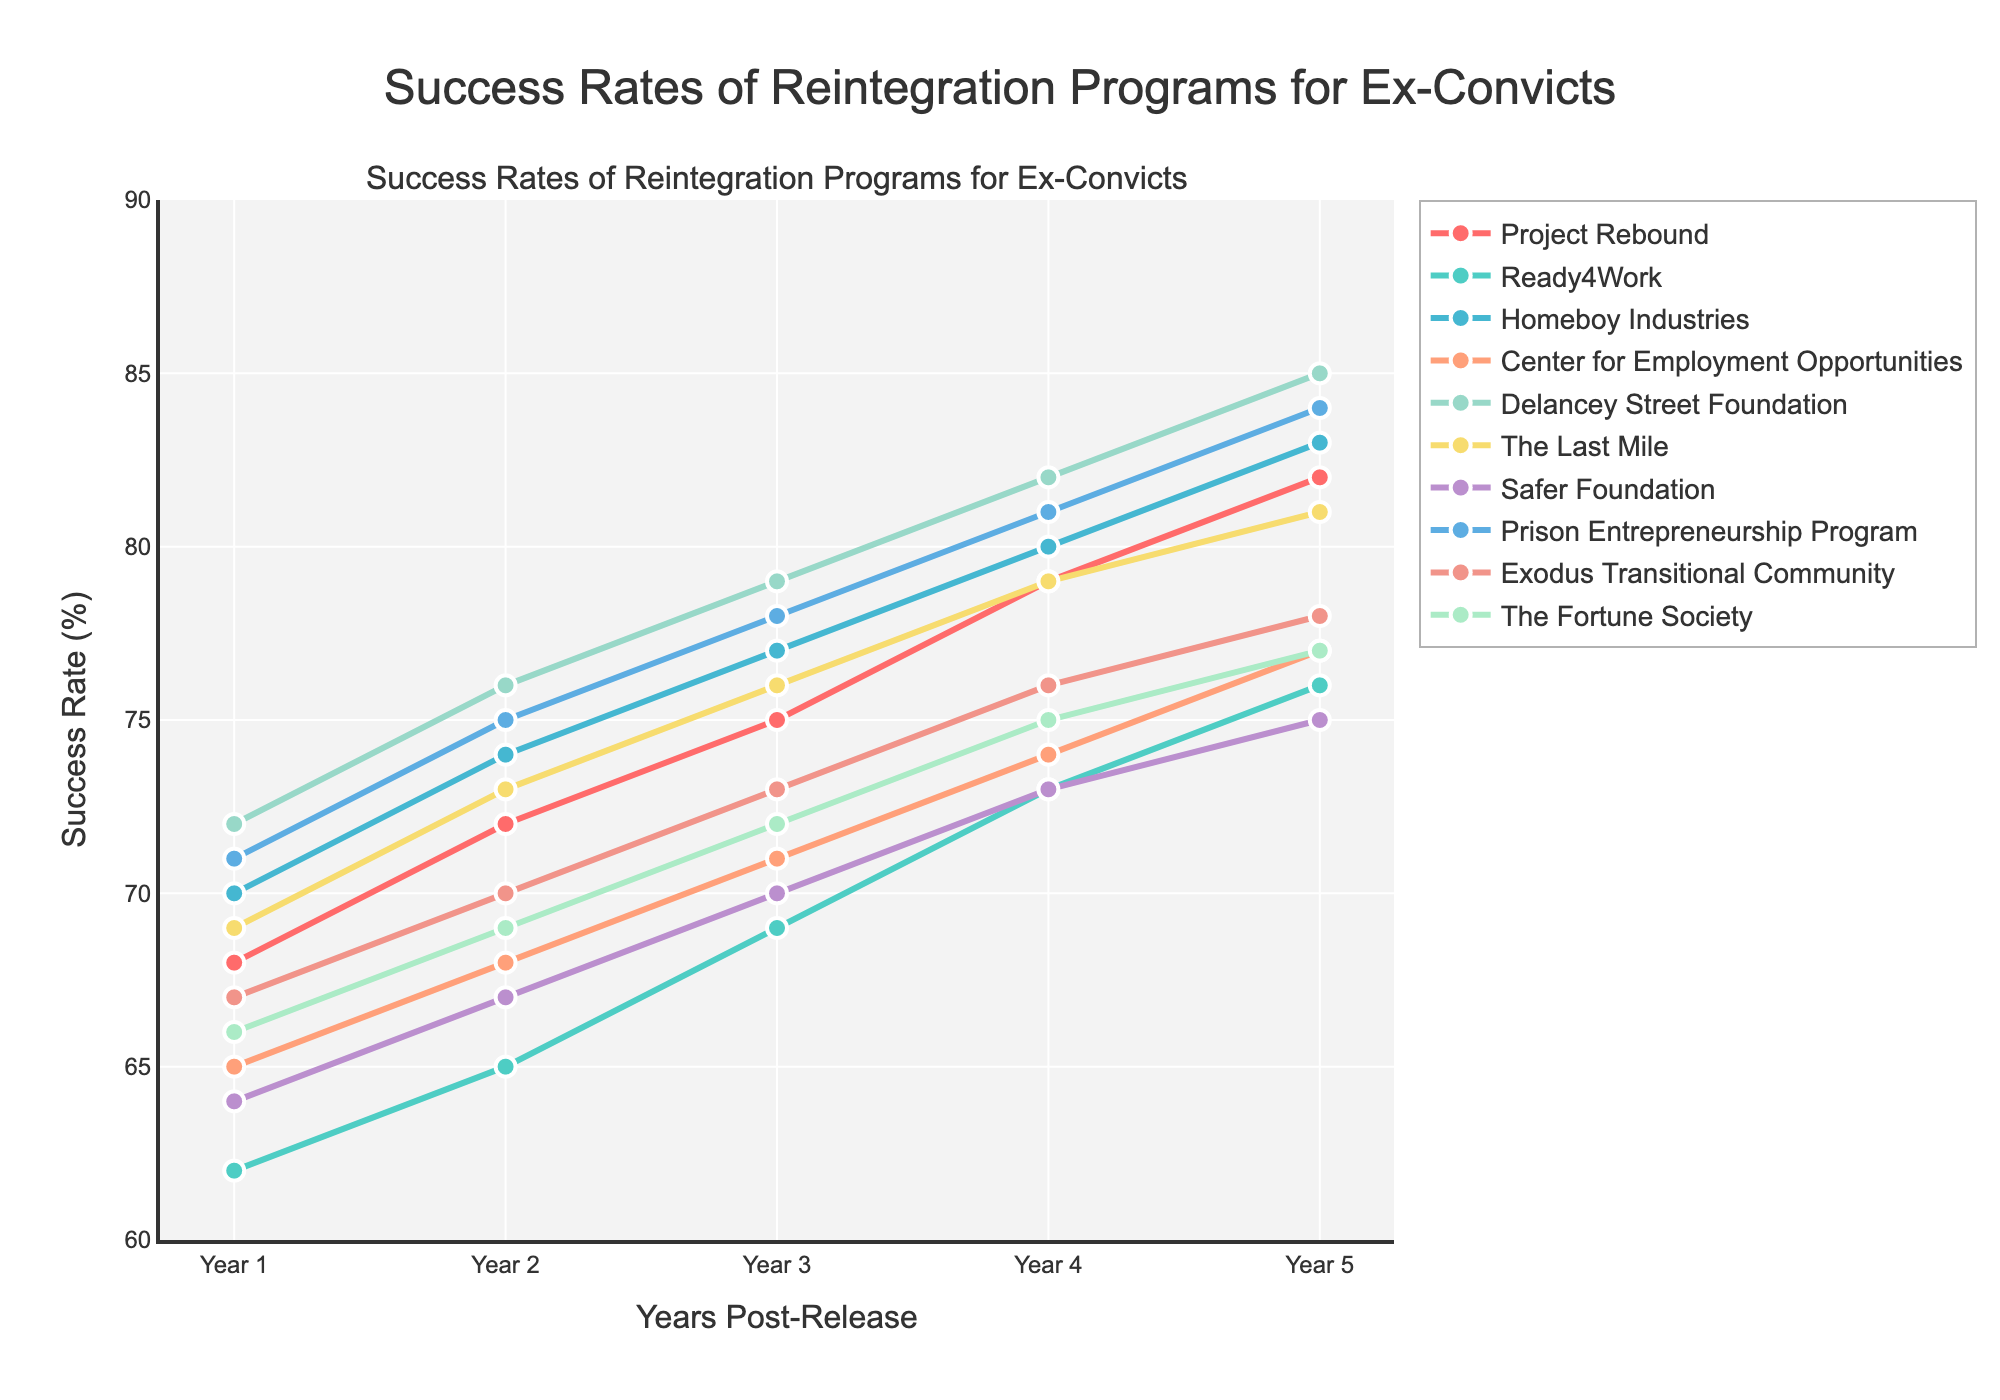Which program has the highest success rate in Year 5? To find the program with the highest success rate in Year 5, look for the highest value in the Year 5 column in the plot. Delancey Street Foundation has the highest success rate at 85%.
Answer: Delancey Street Foundation How does the success rate of Homeboy Industries compare to Exodus Transitional Community in Year 3? Locate the values for Homeboy Industries and Exodus Transitional Community in Year 3 on the plot. Homeboy Industries has a rate of 77%, and Exodus Transitional Community has a rate of 73%. 77% is higher than 73%.
Answer: Homeboy Industries has a higher success rate What is the average success rate across all programs in Year 2? Sum up the success rates of all programs in Year 2 and then divide by the number of programs. The sum is 72 + 65 + 74 + 68 + 76 + 73 + 67 + 75 + 70 + 69 = 709. There are 10 programs, so the average is 709/10 = 70.9%.
Answer: 70.9% Which program shows the most improvement from Year 1 to Year 5? To determine which program shows the most improvement, calculate the difference between Year 5 and Year 1 for each program and identify the largest difference. Delancey Street Foundation improved from 72% to 85%, a difference of 13%. No other program has a difference as large.
Answer: Delancey Street Foundation Among Project Rebound, Ready4Work, and Safer Foundation, which has consistently higher success rates over the five years? Compare the values for Project Rebound, Ready4Work, and Safer Foundation across all five years. Project Rebound has higher values consistently compared to the other two programs: it starts at 68% in Year 1 and ends at 82% in Year 5.
Answer: Project Rebound Which programs have success rates above 80% in Year 5? Check the Year 5 success rates in the plot and identify the programs with rates over 80%. Delancey Street Foundation (85%), Homeboy Industries (83%), and Prison Entrepreneurship Program (84%) are above 80%.
Answer: Delancey Street Foundation, Homeboy Industries, Prison Entrepreneurship Program 